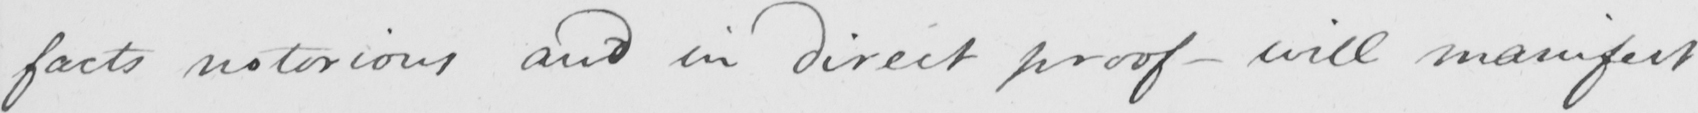Can you read and transcribe this handwriting? facts notorious and in direct proof  _  will manifest 